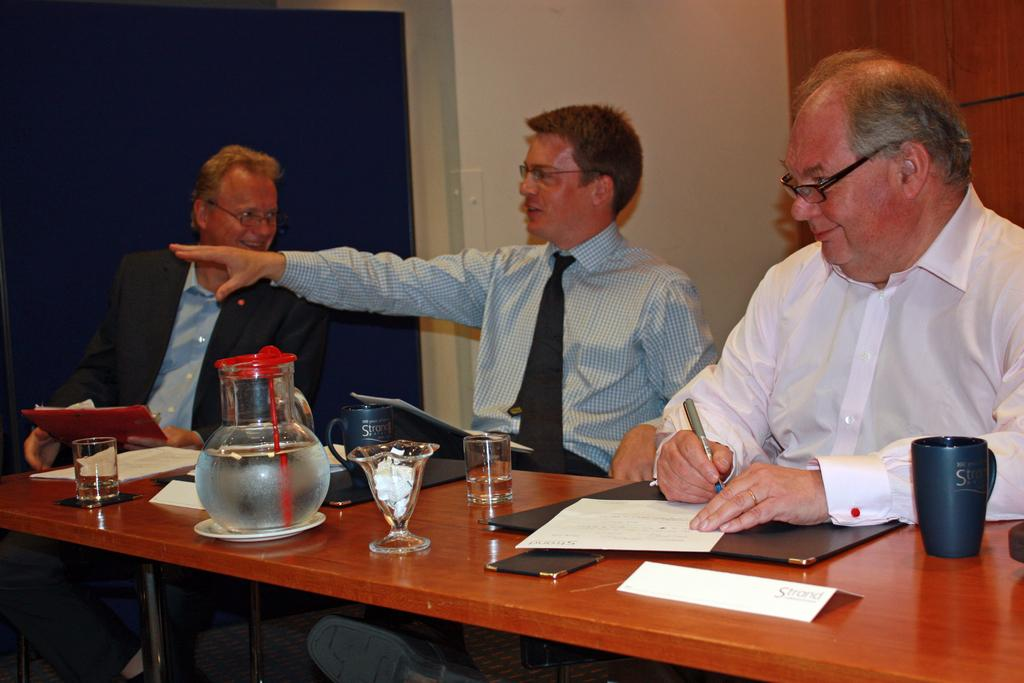How many people are in the image? There are three people in the image. What are the people doing in the image? The people are sitting on a chair and smiling. What objects can be seen on the table in the image? A cup, a file, a glass, and a jar of water are present on the table. What type of berry is being served on the pizzas in the image? There are no pizzas or berries present in the image. What type of work does the laborer perform in the image? There is no laborer present in the image. 